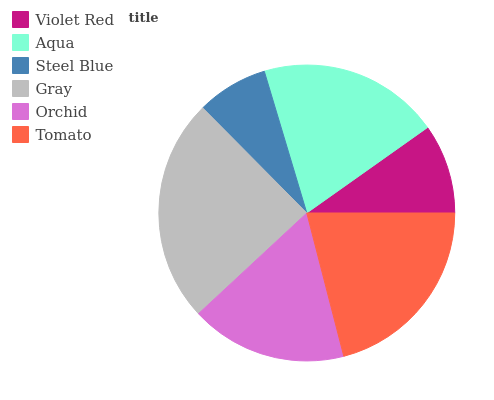Is Steel Blue the minimum?
Answer yes or no. Yes. Is Gray the maximum?
Answer yes or no. Yes. Is Aqua the minimum?
Answer yes or no. No. Is Aqua the maximum?
Answer yes or no. No. Is Aqua greater than Violet Red?
Answer yes or no. Yes. Is Violet Red less than Aqua?
Answer yes or no. Yes. Is Violet Red greater than Aqua?
Answer yes or no. No. Is Aqua less than Violet Red?
Answer yes or no. No. Is Aqua the high median?
Answer yes or no. Yes. Is Orchid the low median?
Answer yes or no. Yes. Is Orchid the high median?
Answer yes or no. No. Is Gray the low median?
Answer yes or no. No. 